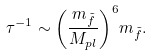Convert formula to latex. <formula><loc_0><loc_0><loc_500><loc_500>\tau ^ { - 1 } \sim { \left ( \frac { m _ { \tilde { f } } } { M _ { p l } } \right ) } ^ { 6 } m _ { \tilde { f } } .</formula> 